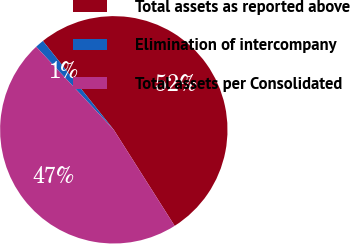Convert chart to OTSL. <chart><loc_0><loc_0><loc_500><loc_500><pie_chart><fcel>Total assets as reported above<fcel>Elimination of intercompany<fcel>Total assets per Consolidated<nl><fcel>51.73%<fcel>1.24%<fcel>47.03%<nl></chart> 